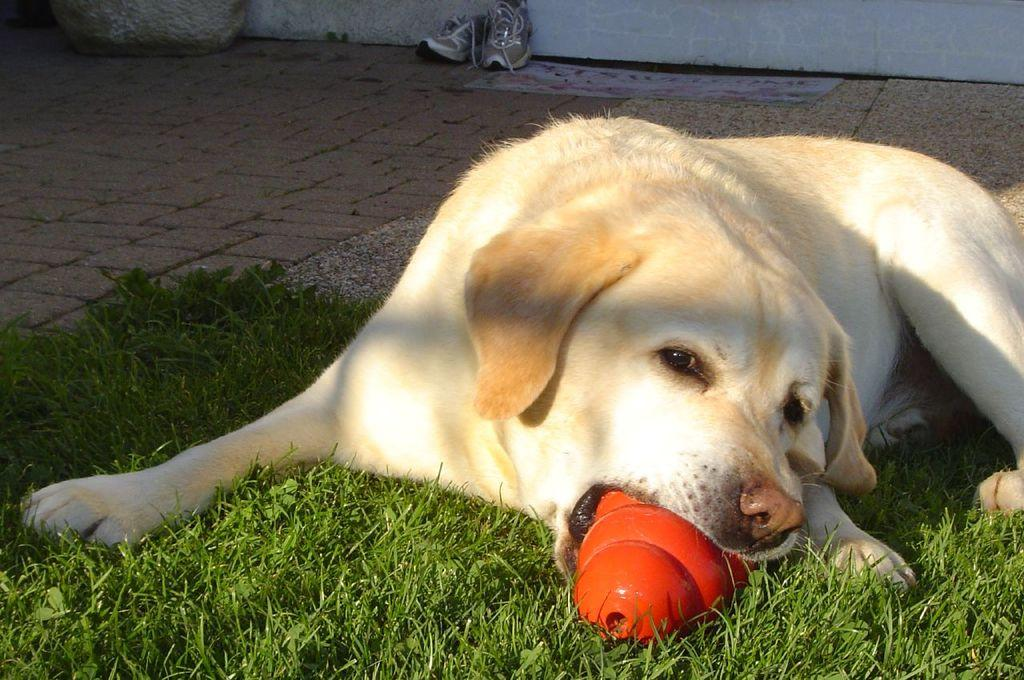What type of animal is present in the image? There is a dog in the image. What is the dog holding in its mouth? The dog has an object in its mouth. What can be seen on the ground in the image? There is a pair of shoes visible on the ground. What type of vegetation is present in the image? There is grass in the image. What type of structure is present in the image? There is a wall in the image. What country does the dog's grandfather come from? There is no mention of a country or a grandfather in the image, so this information cannot be determined. 